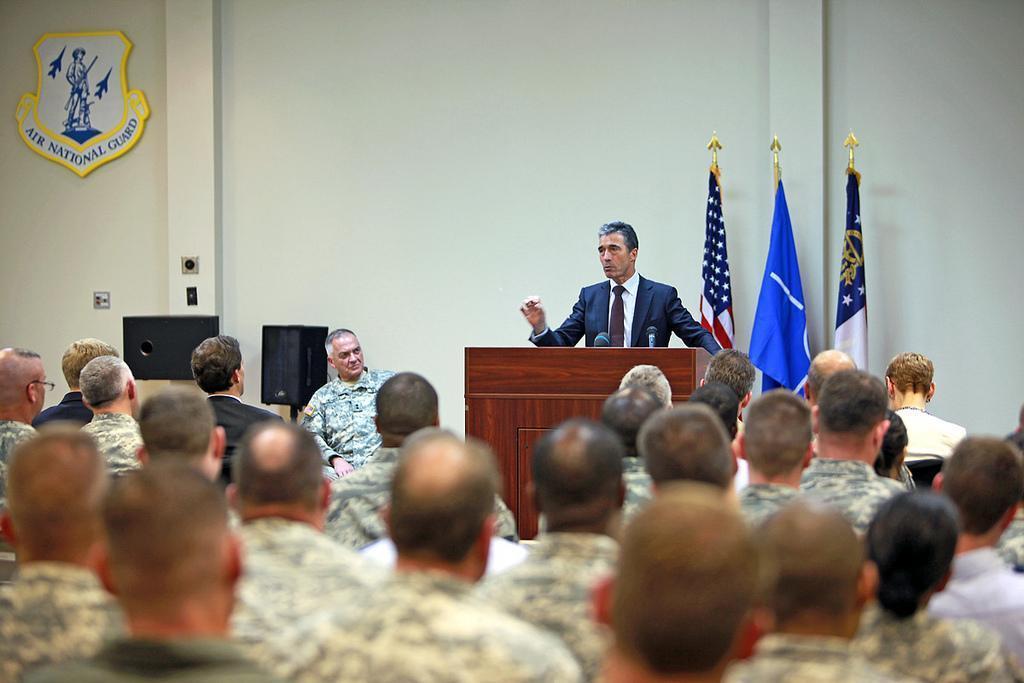How many flags are pictured?
Give a very brief answer. 3. How many flags?
Give a very brief answer. 3. How many flags are there?
Give a very brief answer. 3. How many American flags are there?
Give a very brief answer. 1. How many flags are behind the speaker?
Give a very brief answer. 3. How many flags are shown?
Give a very brief answer. 3. How many flags are visible?
Give a very brief answer. 3. How many men are seated by the podium?
Give a very brief answer. 1. How many men are visible in the audience that aren't wearing military clothing?
Give a very brief answer. 2. 